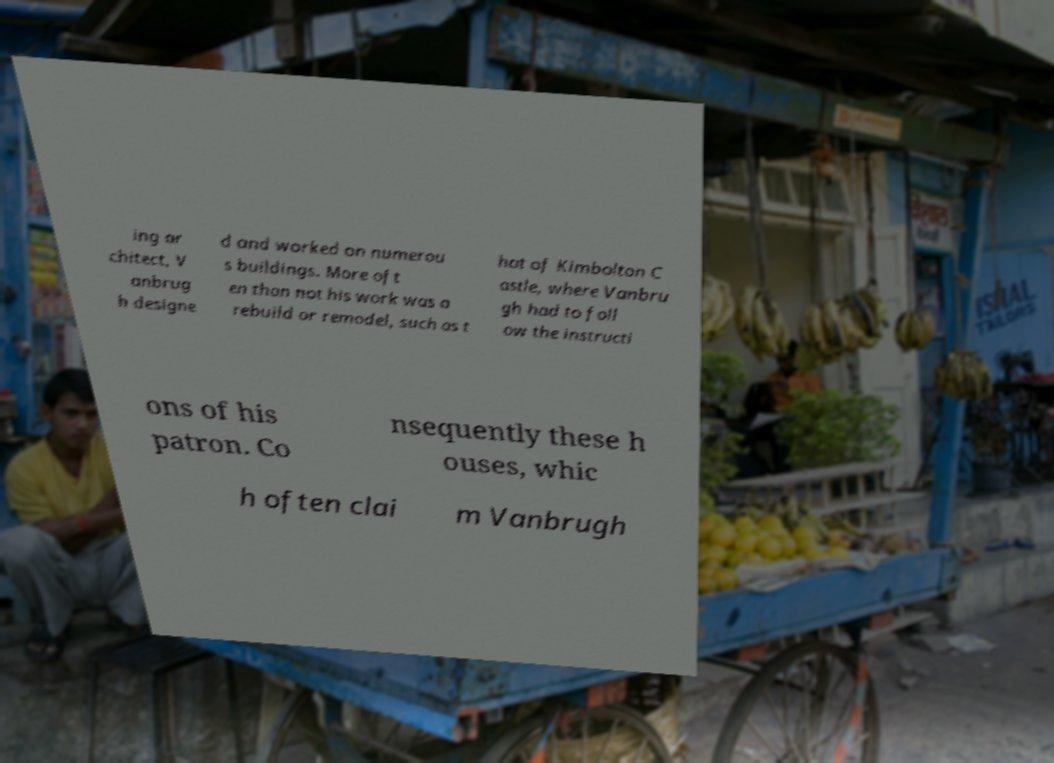Can you read and provide the text displayed in the image?This photo seems to have some interesting text. Can you extract and type it out for me? ing ar chitect, V anbrug h designe d and worked on numerou s buildings. More oft en than not his work was a rebuild or remodel, such as t hat of Kimbolton C astle, where Vanbru gh had to foll ow the instructi ons of his patron. Co nsequently these h ouses, whic h often clai m Vanbrugh 